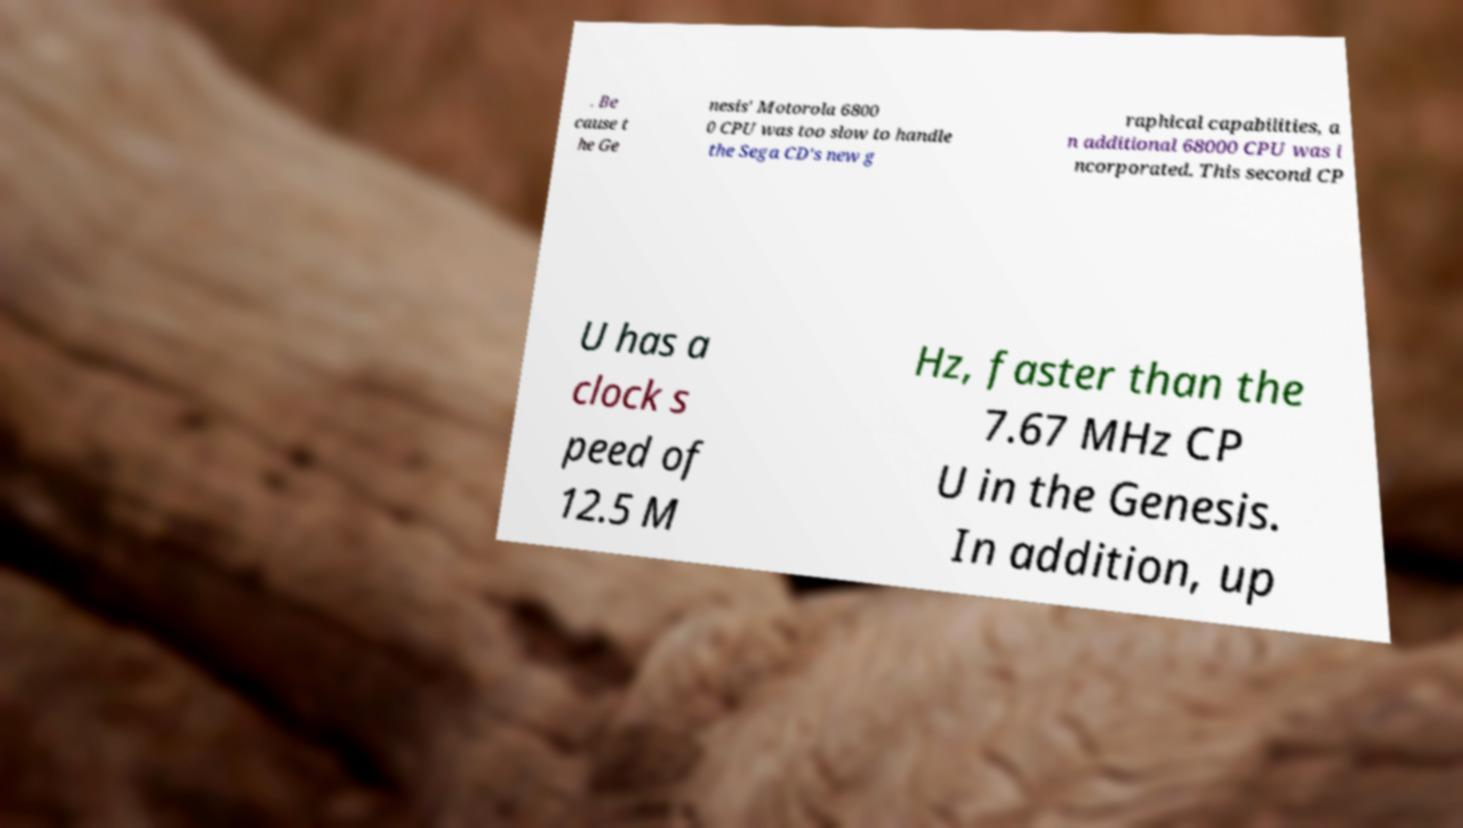Could you extract and type out the text from this image? . Be cause t he Ge nesis' Motorola 6800 0 CPU was too slow to handle the Sega CD's new g raphical capabilities, a n additional 68000 CPU was i ncorporated. This second CP U has a clock s peed of 12.5 M Hz, faster than the 7.67 MHz CP U in the Genesis. In addition, up 